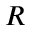Convert formula to latex. <formula><loc_0><loc_0><loc_500><loc_500>R</formula> 